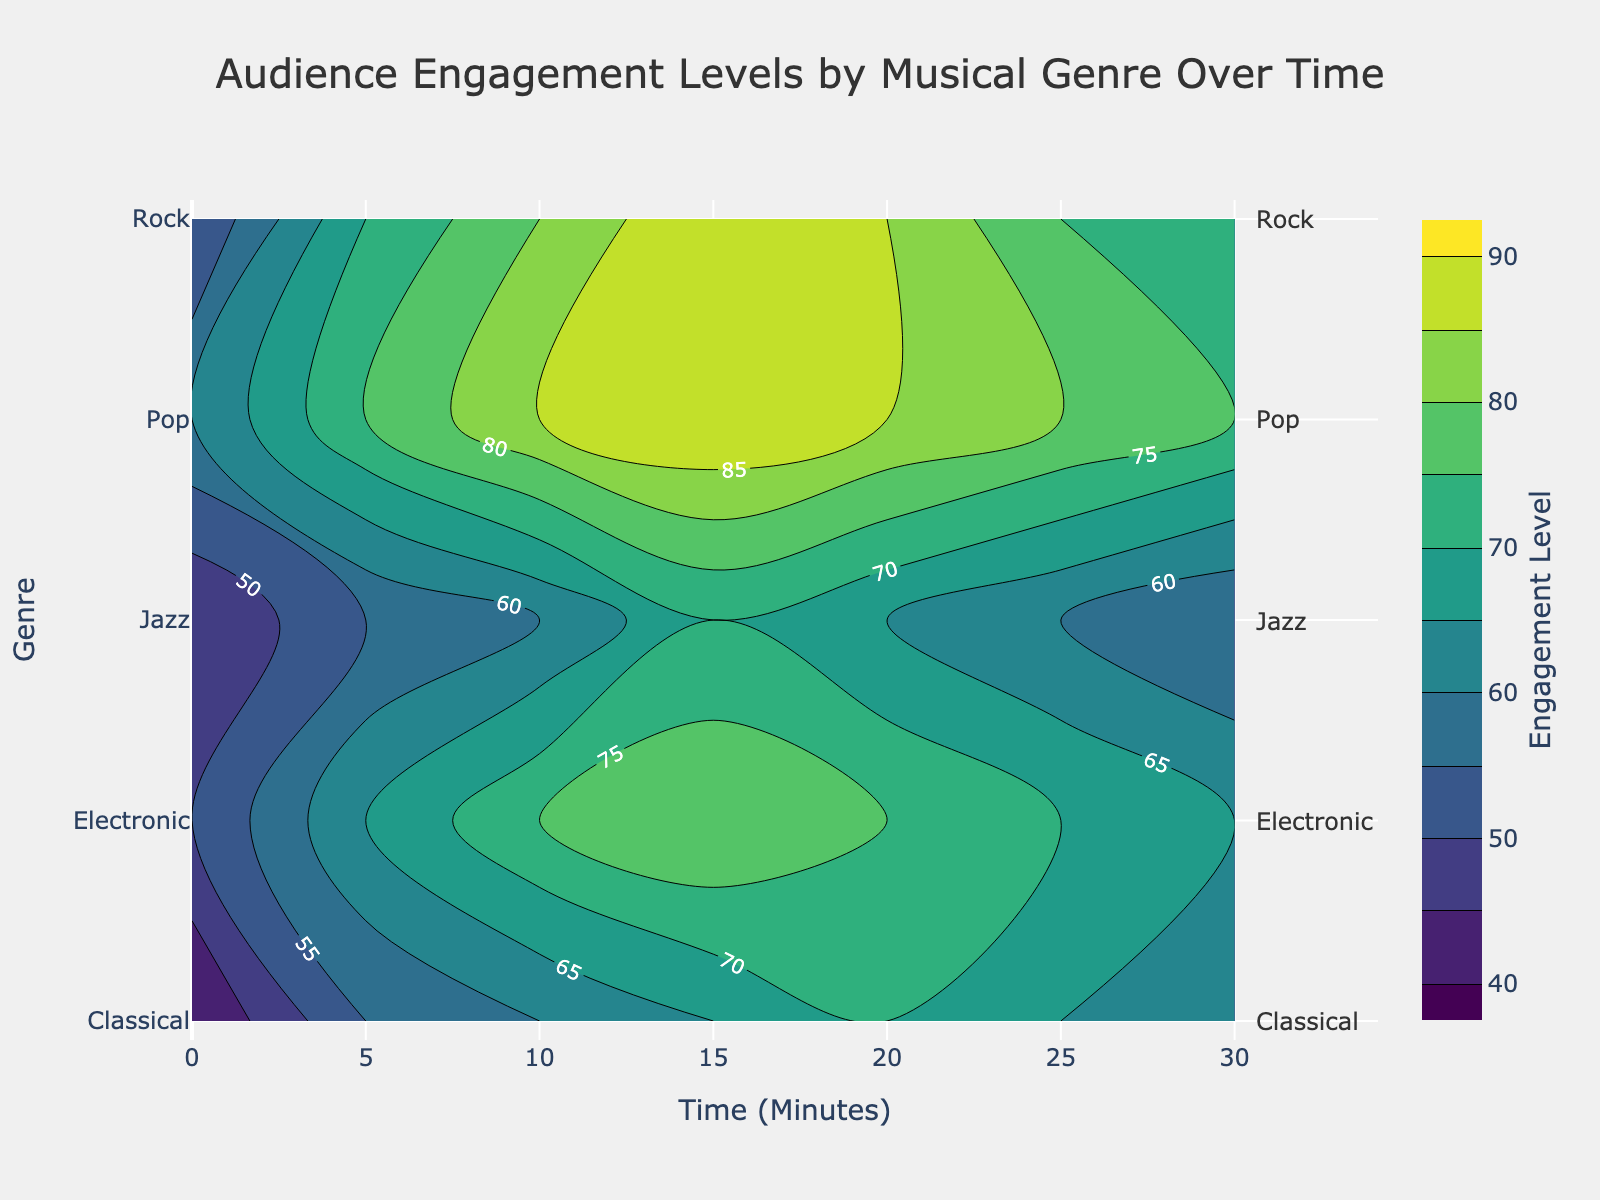what is the title of the figure? The title can be found at the top-center of the figure. It reads "Audience Engagement Levels by Musical Genre Over Time".
Answer: Audience Engagement Levels by Musical Genre Over Time What are the axis titles of the figure? The x-axis and y-axis titles are labeled at the bottom and left side of the figure, respectively. The x-axis is labeled "Time (Minutes)" and the y-axis is labeled "Genre".
Answer: Time (Minutes) and Genre Which genre shows the highest level of audience engagement at any point in time? By examining the contour plot, P20, P25, and P30 appear to peak at the highest engagement levels shown by the brighter color-shade, particularly during the "Pop" genre segment.
Answer: Pop At which time do 'Rock' and 'Electronic' genres have the exact same engagement level? The specific engagement levels where these two genres intersect on the contour can be visually traced. At the 20-minute mark, both genres show an engagement level of 75.
Answer: 20 minutes How does the 'Jazz' engagement level change from the beginning to the end of the performance? By following the 'Jazz' row from 0 to 30 minutes marker, the engagement level starts at 45, increases to 70 at around 15 minutes, and then drops to 55 by the 30-minute mark.
Answer: Starts at 45, peaks at 70, ends at 55 Which genre shows the most steady increase in engagement without any significant drops? Looking closely at the contour lines for each genre, 'Pop' maintains a consistent increase basically without any dropping point, which can be seen advancing in brighter contour shades.
Answer: Pop What is the difference in engagement level between 'Classical' and 'Rock' at the 10-minute mark? From the contours, 'Classical' at 10 minutes is around 60, while 'Rock' is around 80. Subtracting the two gives a difference of 20.
Answer: 20 During which time frame does the 'Classical' genre have its peak engagement level? Observing the 'Classical' engagement levels, the peak is reached at the 20-minute mark.
Answer: 20 minutes Identify the range of engagement levels plotted on the color bar. The color bar on the right side of the figure delineate the engagement levels starting from 40 up to 90.
Answer: 40 to 90 Which genres have engagement levels that drop immediately after reaching their peak? By tracing the contour path for decreases after a peak, both 'Classical' after 20 minutes and 'Electronic' after 15 minutes show an immediate drop in levels.
Answer: Classical and Electronic 